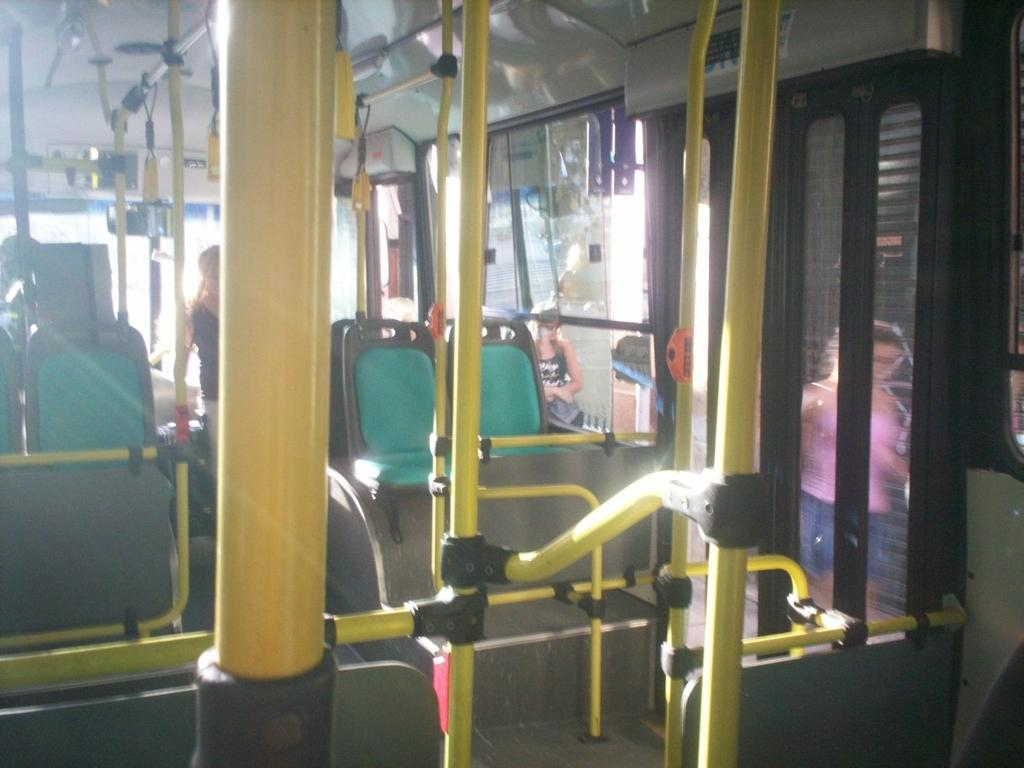What type of seating is visible in the image? There are seats in the image. What else can be seen in the image besides the seats? There are rods and windows visible in the image. What can be inferred about the setting of the image? The setting appears to be inside a bus. Where are the windows located in the image? There are windows on the right side of the image. What else is present on the right side of the image? There is a door on the right side of the image. What is happening outside the windows? Two women are visible outside the windows. What type of peace is being promoted by the force visible in the image? There is no reference to peace or force in the image; it depicts a bus interior with seats, rods, windows, a door, and two women outside the windows. 